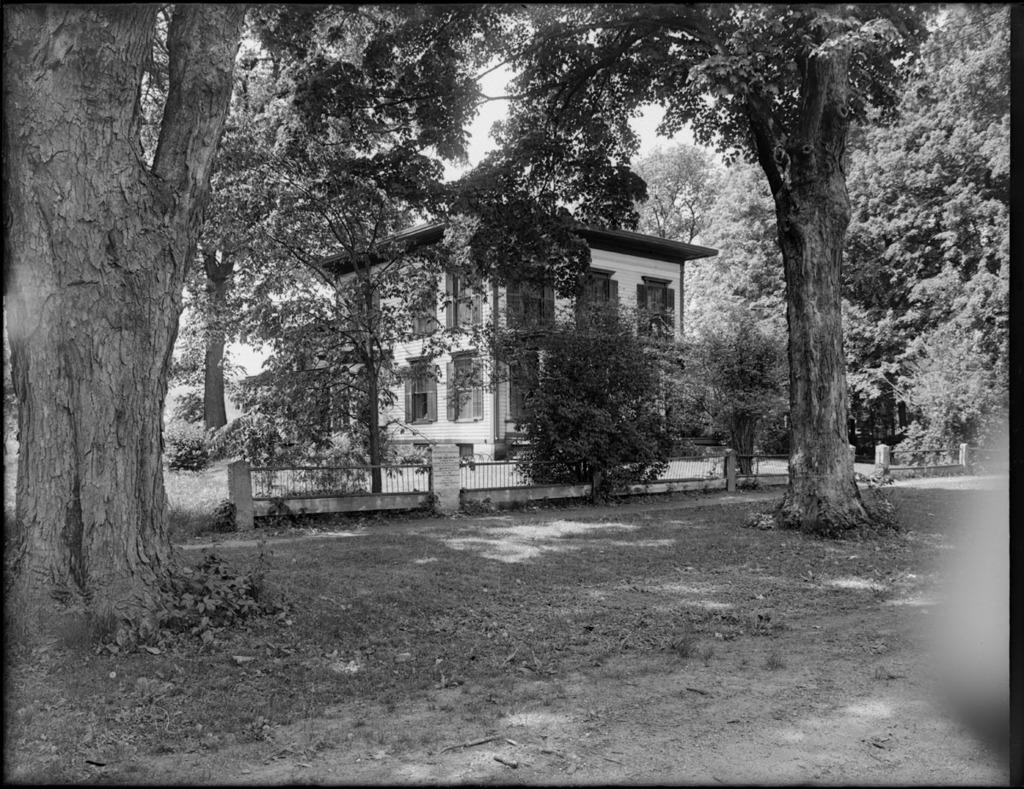What type of natural elements can be seen in the image? There are trees in the image. What type of path is present in the image? There is a walkway in the image. What can be seen in the background of the image? There is fencing and a house in the background of the image. What is visible at the top of the image? The sky is clear and visible at the top of the image. What type of advertisement can be seen on the trees in the image? There are no advertisements present on the trees in the image. How many brothers are visible in the image? There are no people, let alone brothers, visible in the image. 